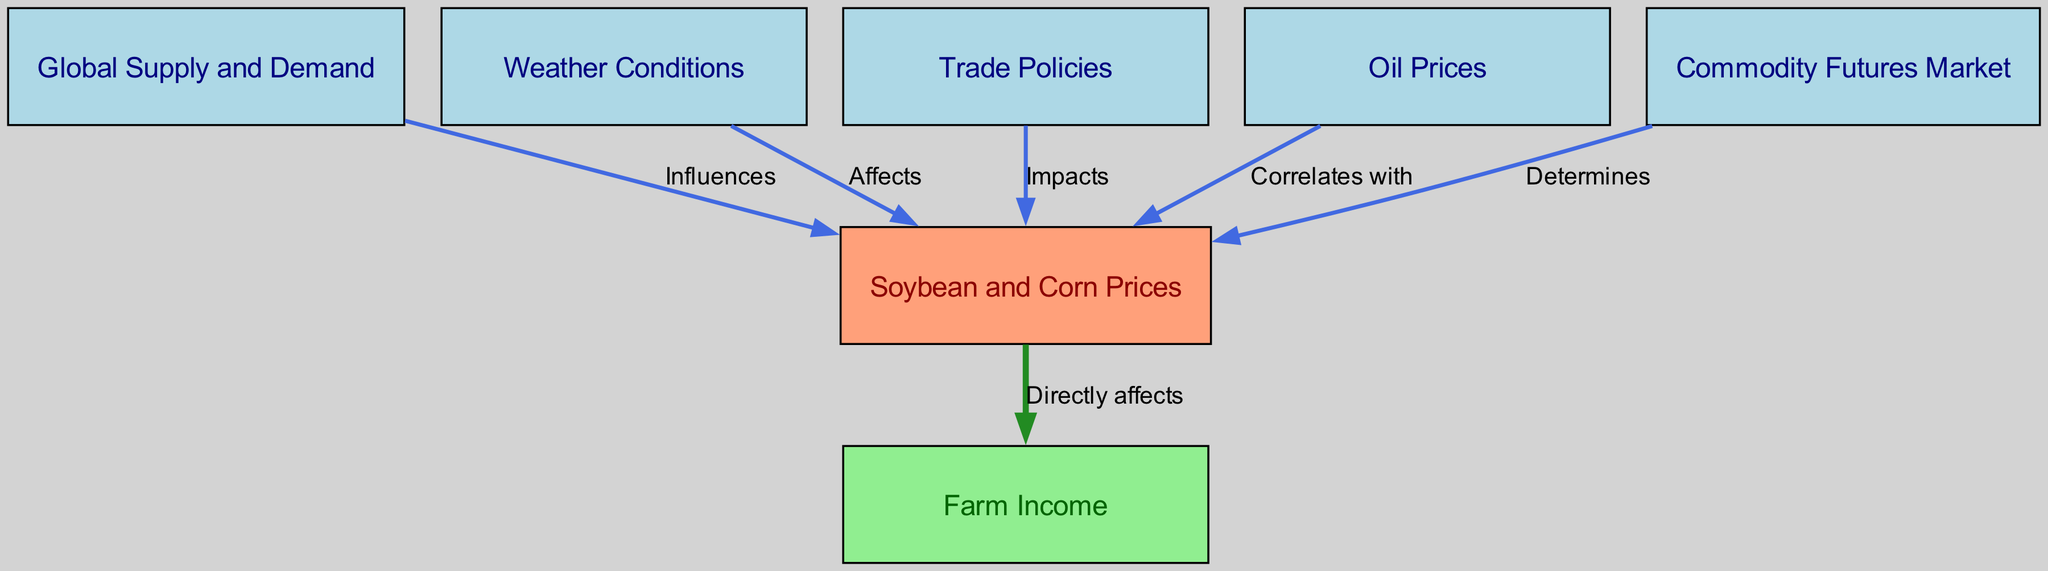What is the main node in this diagram? The main node is "Soybean and Corn Prices," which is identified by its unique position in the diagram where multiple influences converge.
Answer: Soybean and Corn Prices How many nodes are present in the diagram? The diagram contains a total of 7 nodes representing various factors that influence the soybean and corn market.
Answer: 7 Which node affects the soybean and corn prices due to weather conditions? The node "Weather Conditions" directly affects the "Soybean and Corn Prices," as indicated by the relationship in the diagram.
Answer: Weather Conditions What type of relationship exists between global supply and demand and soybean and corn prices? The relationship is described as "Influences," showing that changes in global supply and demand can lead to price fluctuations in the soybean and corn market.
Answer: Influences Which factors directly correlate with soybean and corn prices in the diagram? The factors listed that correlate with soybean and corn prices are "Global Supply and Demand," "Weather Conditions," "Trade Policies," and "Oil Prices."
Answer: Global Supply and Demand, Weather Conditions, Trade Policies, Oil Prices How does the commodity futures market relate to soybean and corn prices? The commodity futures market "Determines" the prices of soybeans and corn, indicating a direct link where futures trading impacts current market prices.
Answer: Determines What is the resulting effect of soybean and corn prices on farm income? The diagram indicates that soybean and corn prices "Directly affects" farm income, showing a clear cause and effect relationship.
Answer: Directly affects Which node impacts soybean and corn prices through trade policies? The node "Trade Policies" is shown to have an "Impacts" relationship with soybean and corn prices, suggesting that regulations and tariffs can influence market prices.
Answer: Trade Policies 